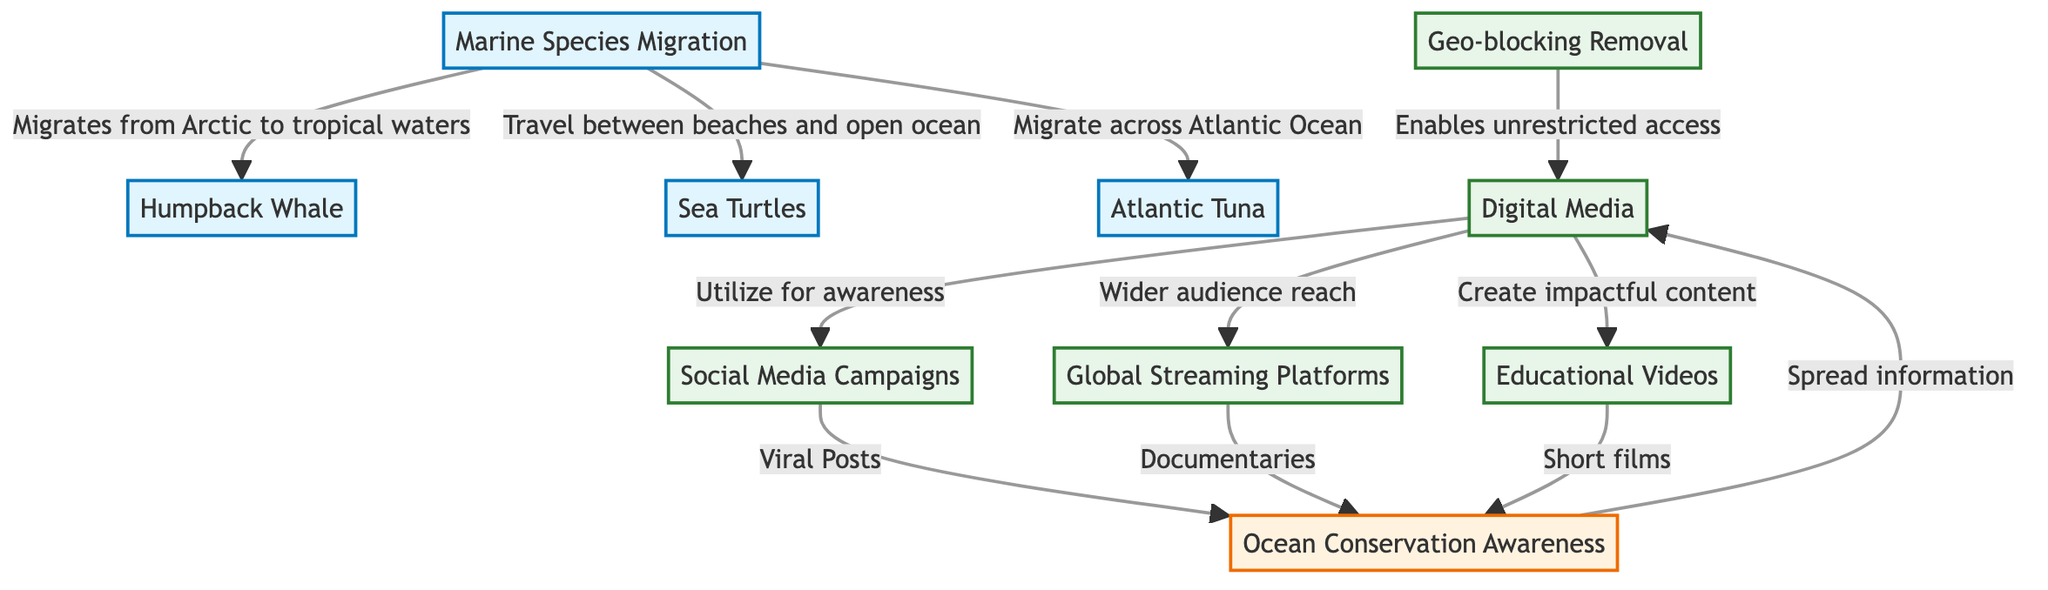What are the three marine species mentioned? The diagram lists Humpback Whale, Sea Turtles, and Atlantic Tuna under the Marine Species Migration node. These are the three species connected to marine migration.
Answer: Humpback Whale, Sea Turtles, Atlantic Tuna What relationship does the Humpback Whale have with migration? The diagram indicates that Humpback Whales migrate from Arctic to tropical waters, establishing a direct connection between the species and their migratory pattern.
Answer: Migrates from Arctic to tropical waters How does digital media contribute to ocean conservation awareness? Digital media is shown to spread information, utilize social media campaigns, reach a wider audience through global streaming platforms, and create impactful content like educational videos, all linking it to ocean conservation awareness.
Answer: Spread information What type of content does Global Streaming Platforms create for awareness? The diagram connects Global Streaming Platforms to Documentaries, indicating that they create documentary content specifically aimed at spreading awareness about ocean conservation.
Answer: Documentaries How many digital media methods are illustrated in the diagram? The diagram lists four distinct methods: Social Media Campaigns, Global Streaming Platforms, Educational Videos, and the removal of Geo-blocking, which totals to four methods of digital media usage for awareness.
Answer: 4 What does the removal of geo-blocking enable? The diagram indicates that the removal of geo-blocking enables unrestricted access to digital media, allowing greater engagement in ocean conservation awareness across different regions.
Answer: Unrestricted access What do social media campaigns aim to do according to the diagram? According to the diagram, social media campaigns aim to produce Viral Posts that contribute to spreading awareness about ocean conservation, demonstrating their role in digital media strategy.
Answer: Viral Posts What are the types of videos mentioned that contribute to awareness? The diagram includes Educational Videos and Short Films as types of video content specifically mentioned to help create awareness about ocean conservation.
Answer: Educational Videos, Short Films Which marine species travels between beaches and open ocean? The diagram indicates that Sea Turtles are the marine species specifically mentioned to travel between beaches and the open ocean, linking their behavior directly to migration.
Answer: Sea Turtles 